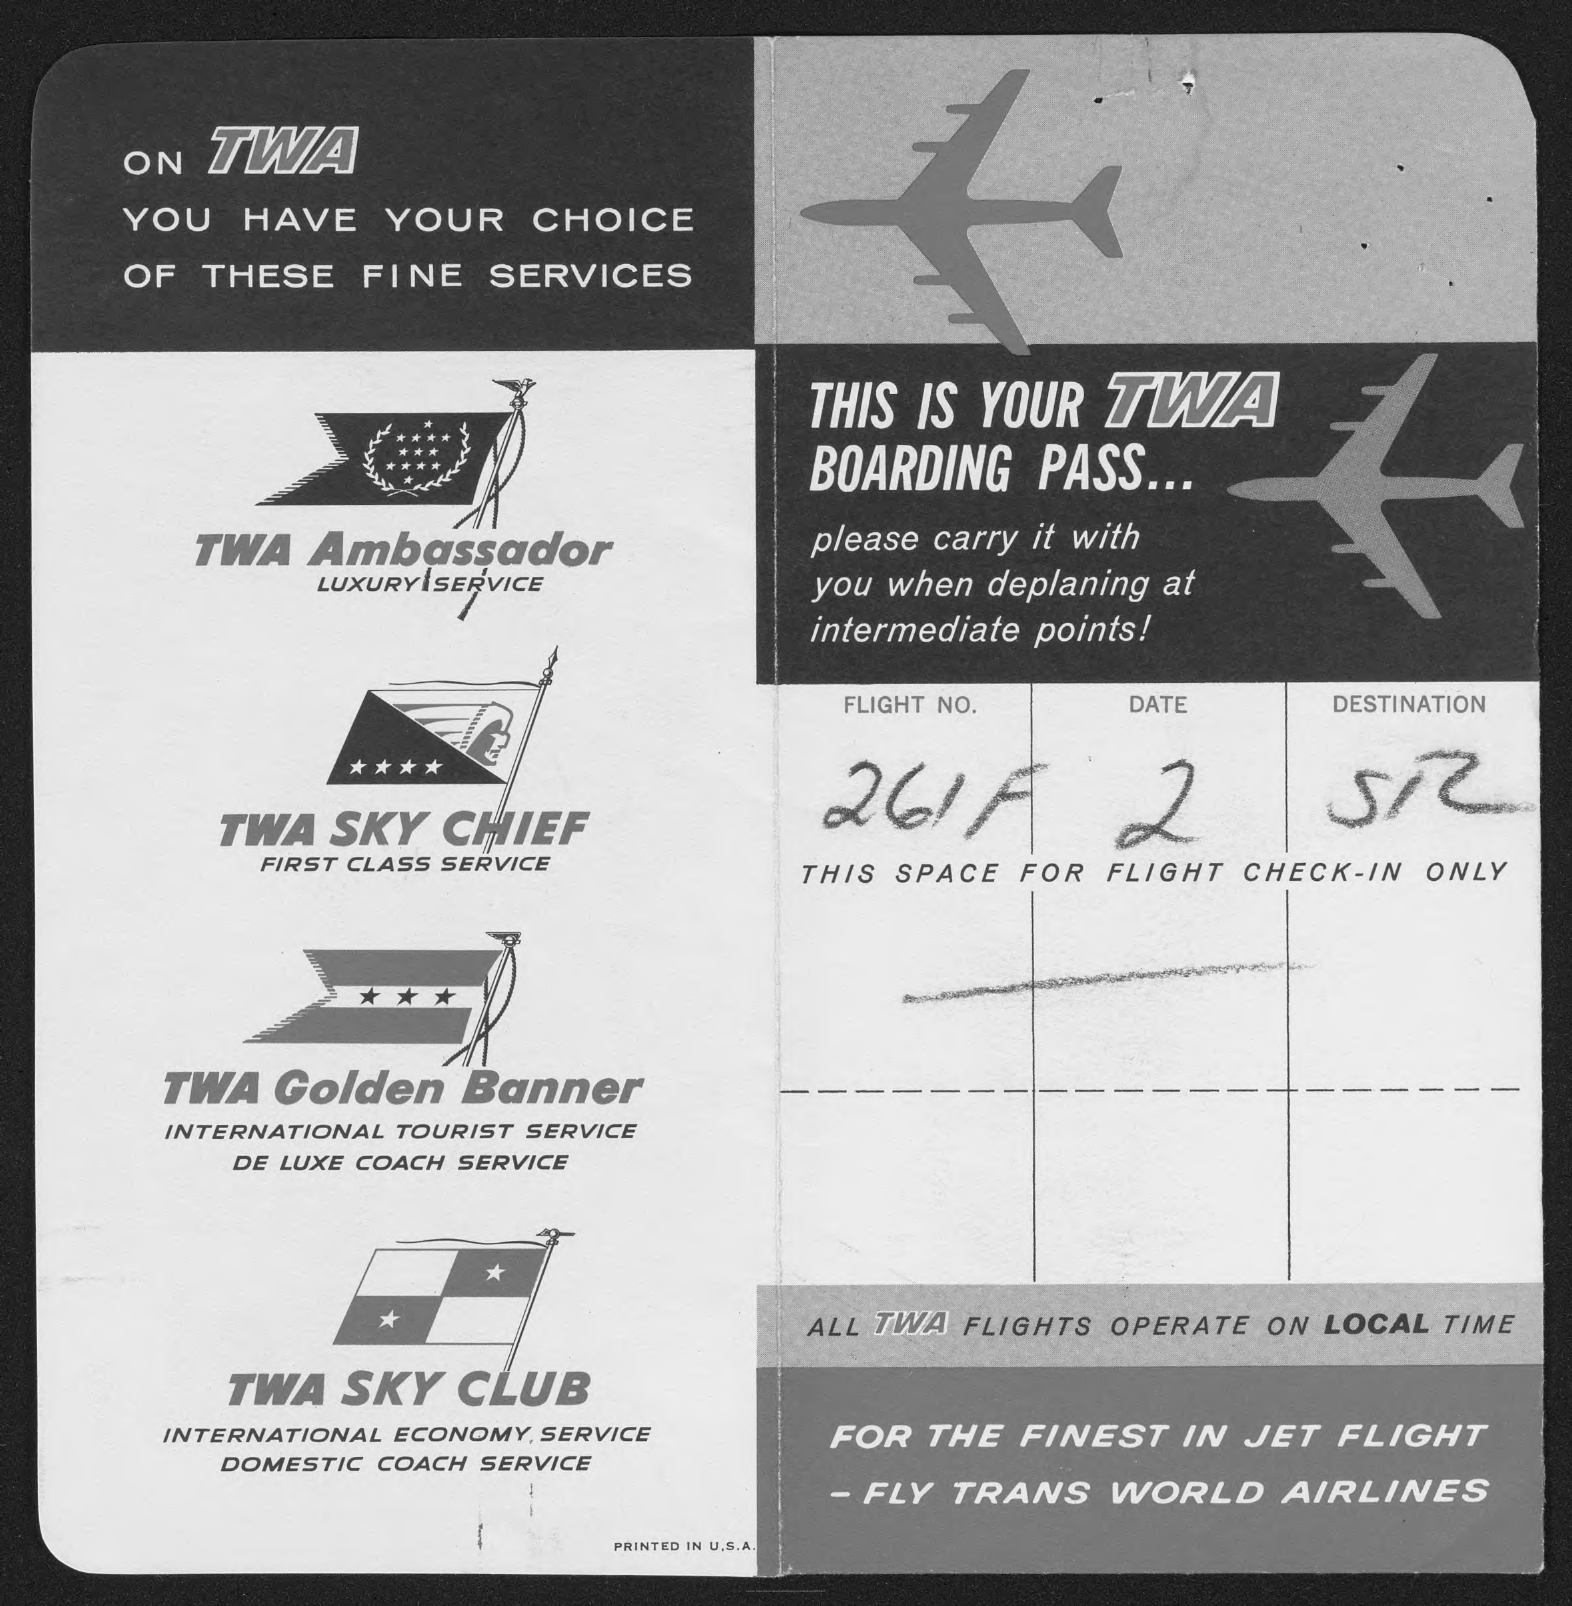Outline some significant characteristics in this image. The flight number indicated on the boarding pass is 261F. The destination listed on the boarding pass is SR. 